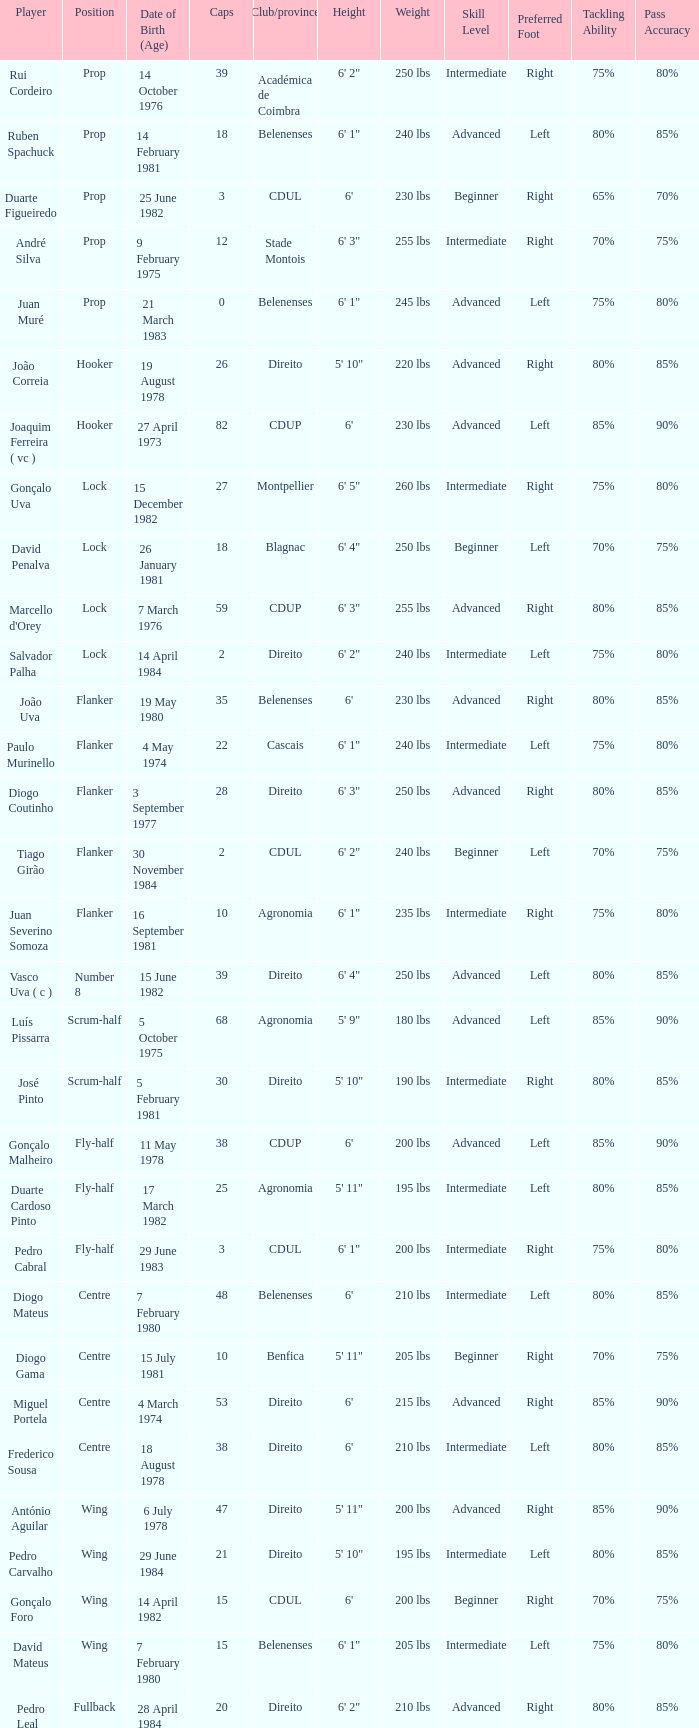Which player has a Position of fly-half, and a Caps of 3? Pedro Cabral. 